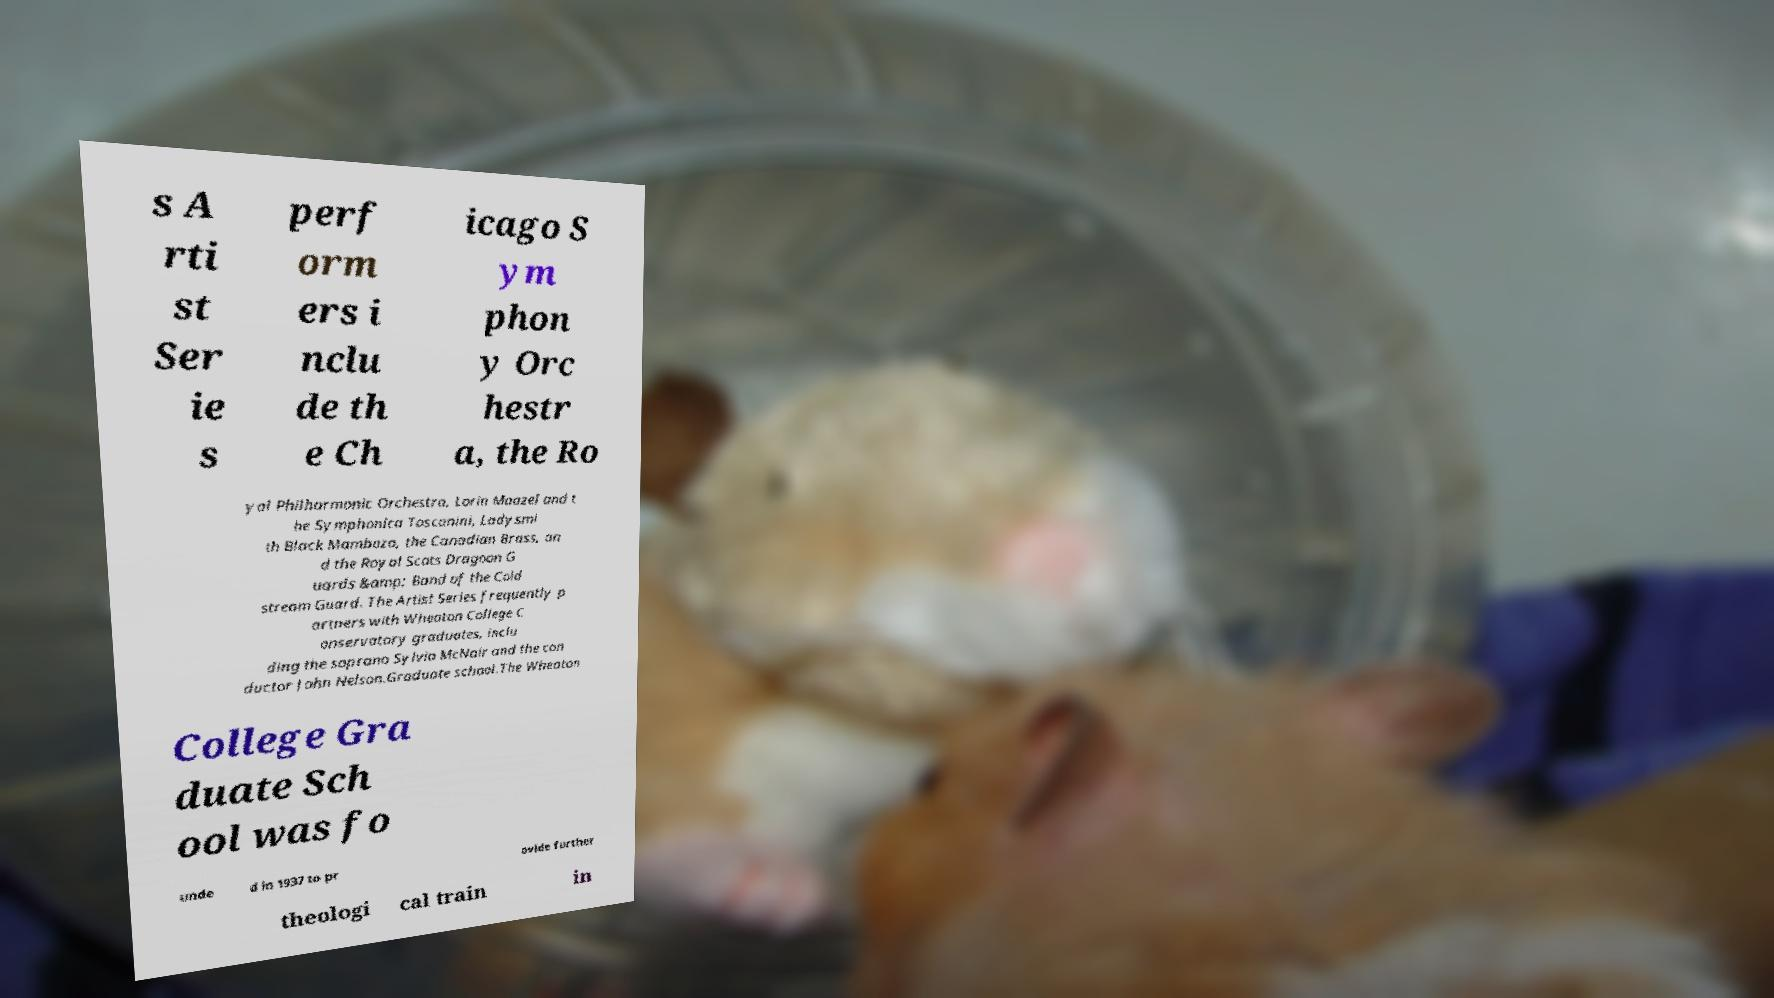Please read and relay the text visible in this image. What does it say? s A rti st Ser ie s perf orm ers i nclu de th e Ch icago S ym phon y Orc hestr a, the Ro yal Philharmonic Orchestra, Lorin Maazel and t he Symphonica Toscanini, Ladysmi th Black Mambazo, the Canadian Brass, an d the Royal Scots Dragoon G uards &amp; Band of the Cold stream Guard. The Artist Series frequently p artners with Wheaton College C onservatory graduates, inclu ding the soprano Sylvia McNair and the con ductor John Nelson.Graduate school.The Wheaton College Gra duate Sch ool was fo unde d in 1937 to pr ovide further theologi cal train in 